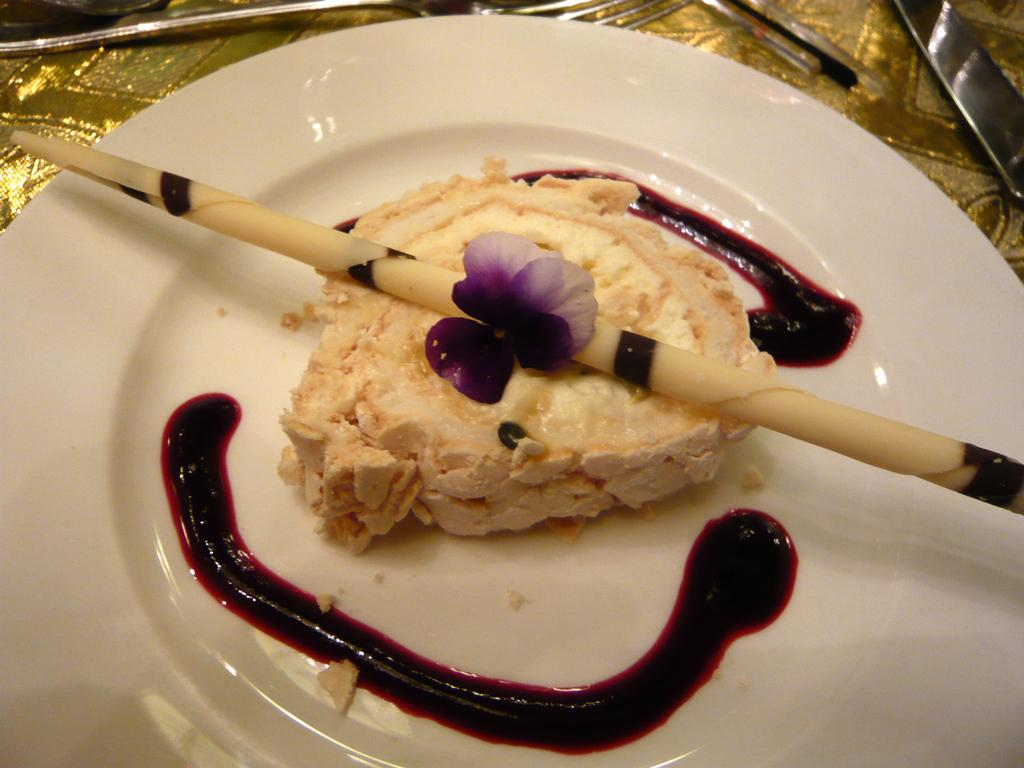What is on the plate in the image? There is pastry on the plate, and there is sauce on the plate as well. What utensils are visible in the image? There are forks visible at the top of the plate. Can you see any rabbits playing on a swing in the image? No, there are no rabbits or swings present in the image. 